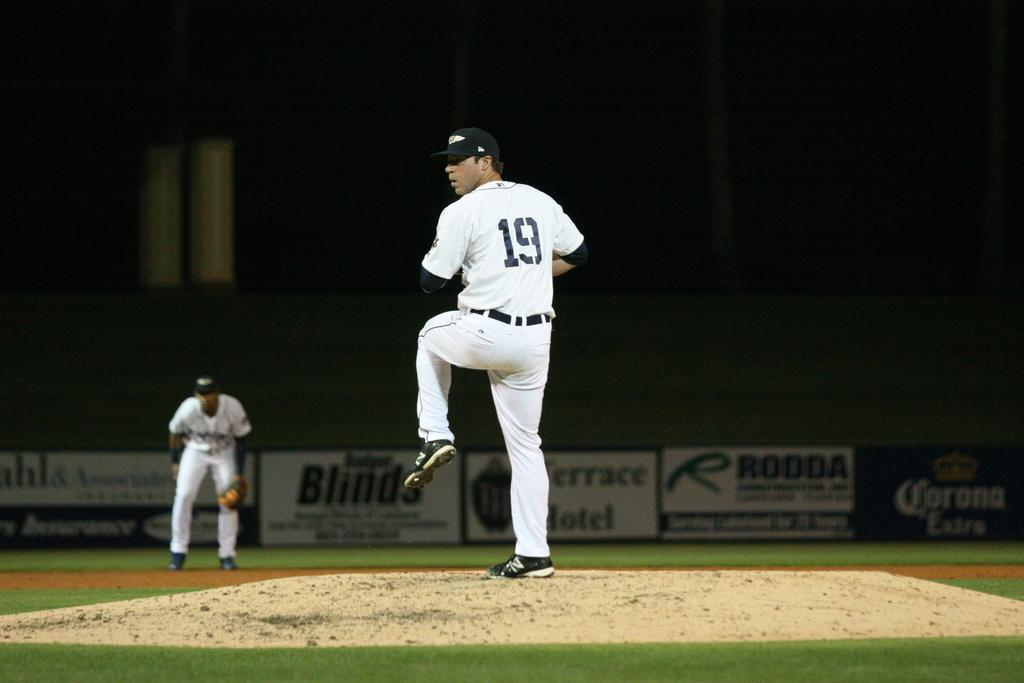<image>
Summarize the visual content of the image. a pitcher with the number 19 on his jersey 